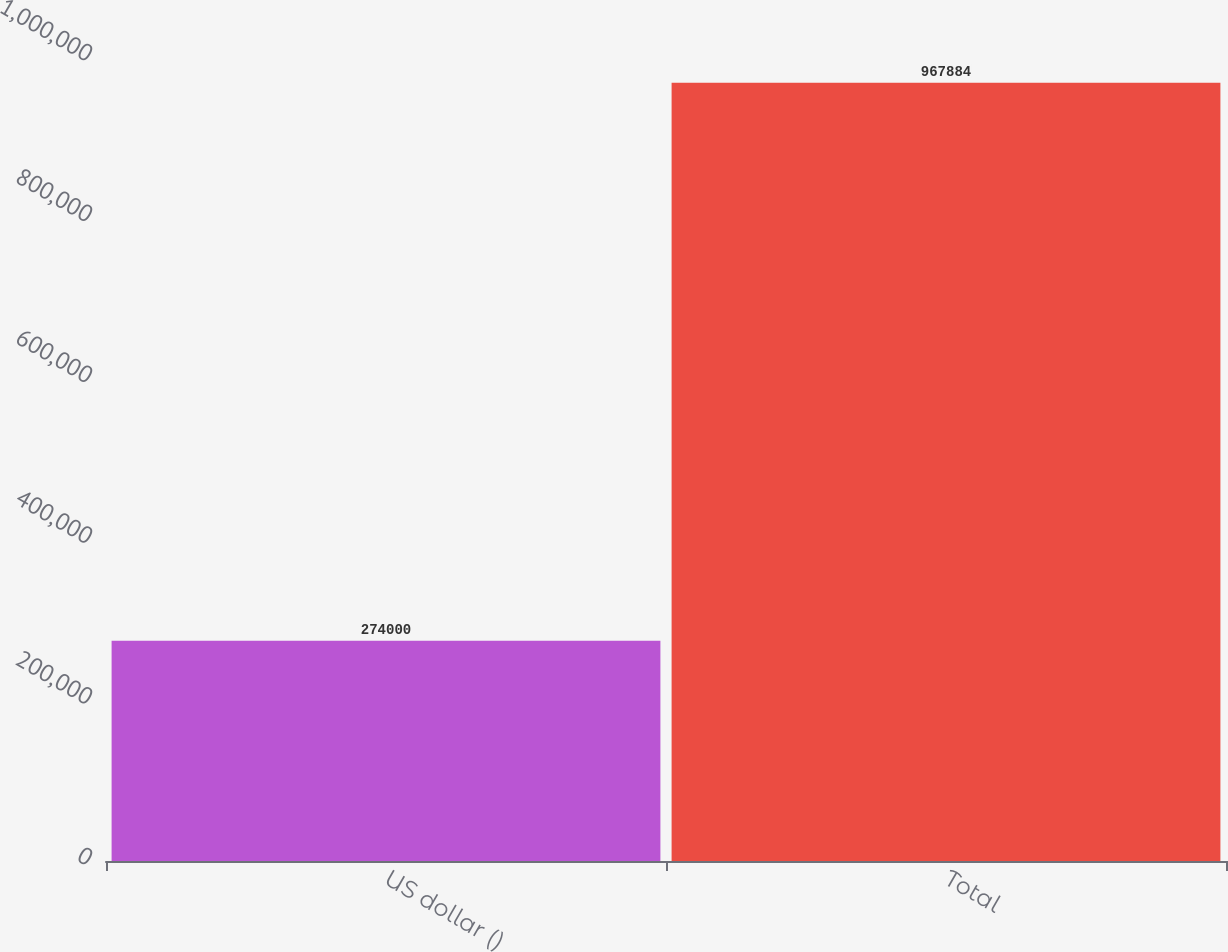Convert chart. <chart><loc_0><loc_0><loc_500><loc_500><bar_chart><fcel>US dollar ()<fcel>Total<nl><fcel>274000<fcel>967884<nl></chart> 